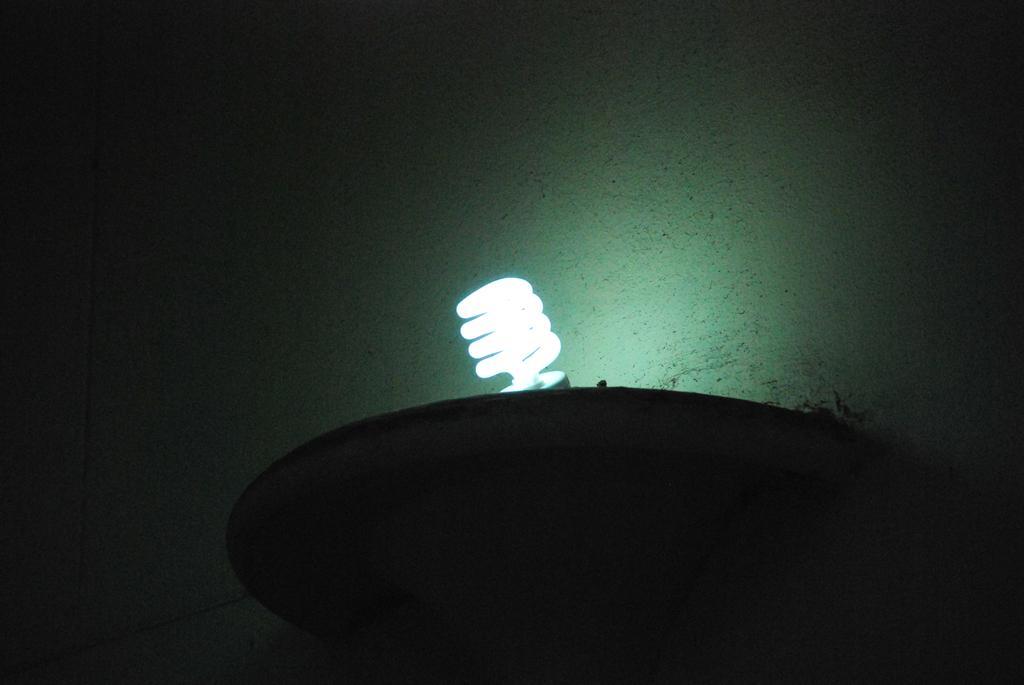How would you summarize this image in a sentence or two? In the image I can see a light bulb and some other objects. In the background I can see a wall. The image is little bit dark. 